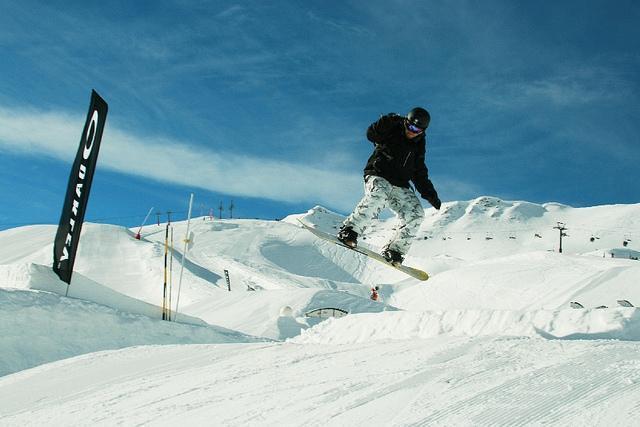How many bowls have eggs?
Give a very brief answer. 0. 